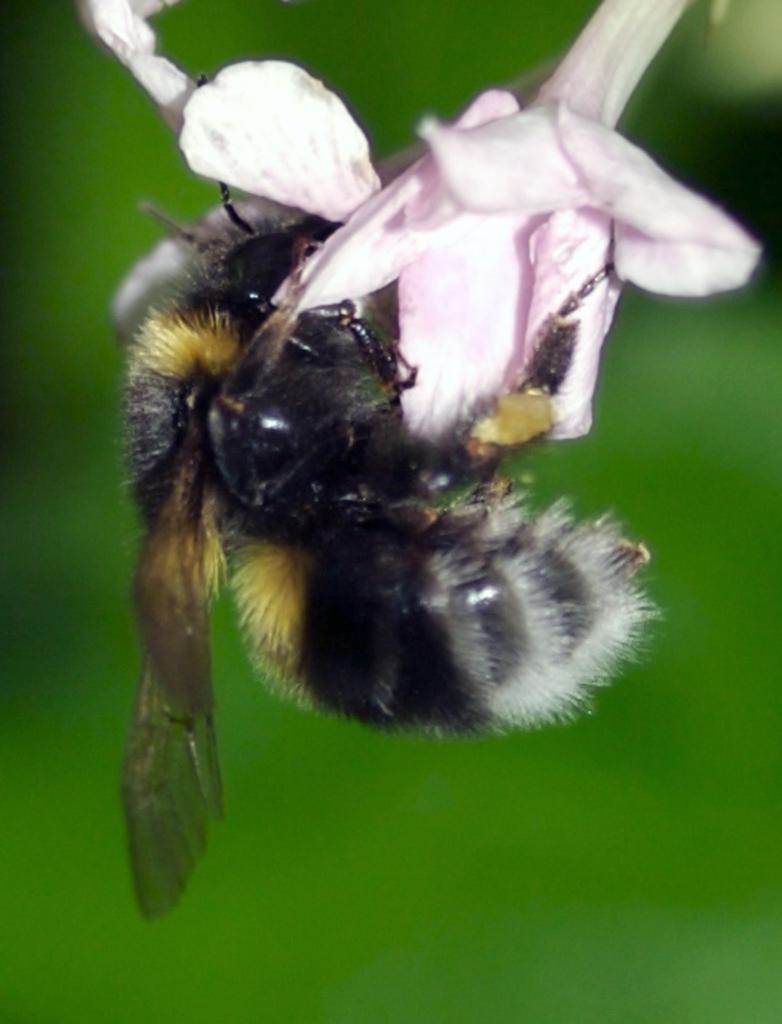Describe this image in one or two sentences. In this image I can see an insect on a flower and the background is blurred. 